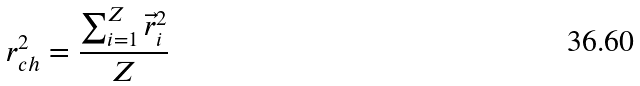<formula> <loc_0><loc_0><loc_500><loc_500>r ^ { 2 } _ { c h } = \frac { \sum _ { i = 1 } ^ { Z } \vec { r } _ { i } ^ { 2 } } { Z }</formula> 